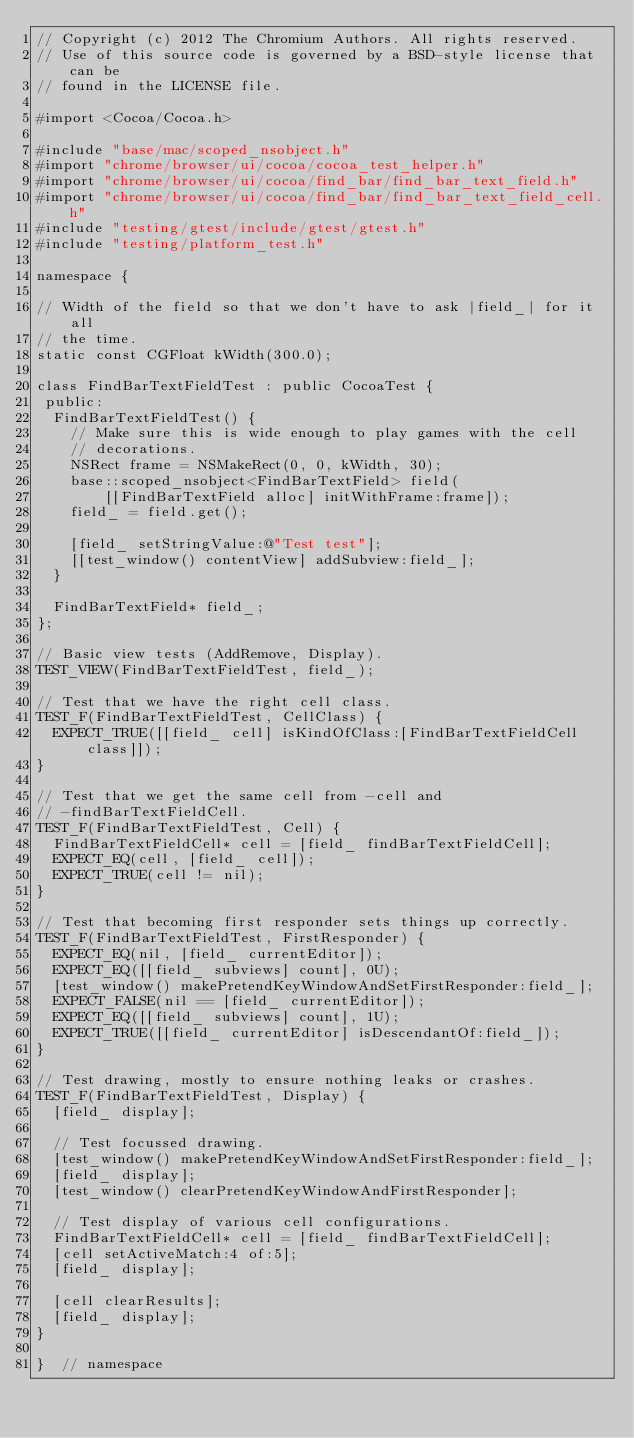<code> <loc_0><loc_0><loc_500><loc_500><_ObjectiveC_>// Copyright (c) 2012 The Chromium Authors. All rights reserved.
// Use of this source code is governed by a BSD-style license that can be
// found in the LICENSE file.

#import <Cocoa/Cocoa.h>

#include "base/mac/scoped_nsobject.h"
#import "chrome/browser/ui/cocoa/cocoa_test_helper.h"
#import "chrome/browser/ui/cocoa/find_bar/find_bar_text_field.h"
#import "chrome/browser/ui/cocoa/find_bar/find_bar_text_field_cell.h"
#include "testing/gtest/include/gtest/gtest.h"
#include "testing/platform_test.h"

namespace {

// Width of the field so that we don't have to ask |field_| for it all
// the time.
static const CGFloat kWidth(300.0);

class FindBarTextFieldTest : public CocoaTest {
 public:
  FindBarTextFieldTest() {
    // Make sure this is wide enough to play games with the cell
    // decorations.
    NSRect frame = NSMakeRect(0, 0, kWidth, 30);
    base::scoped_nsobject<FindBarTextField> field(
        [[FindBarTextField alloc] initWithFrame:frame]);
    field_ = field.get();

    [field_ setStringValue:@"Test test"];
    [[test_window() contentView] addSubview:field_];
  }

  FindBarTextField* field_;
};

// Basic view tests (AddRemove, Display).
TEST_VIEW(FindBarTextFieldTest, field_);

// Test that we have the right cell class.
TEST_F(FindBarTextFieldTest, CellClass) {
  EXPECT_TRUE([[field_ cell] isKindOfClass:[FindBarTextFieldCell class]]);
}

// Test that we get the same cell from -cell and
// -findBarTextFieldCell.
TEST_F(FindBarTextFieldTest, Cell) {
  FindBarTextFieldCell* cell = [field_ findBarTextFieldCell];
  EXPECT_EQ(cell, [field_ cell]);
  EXPECT_TRUE(cell != nil);
}

// Test that becoming first responder sets things up correctly.
TEST_F(FindBarTextFieldTest, FirstResponder) {
  EXPECT_EQ(nil, [field_ currentEditor]);
  EXPECT_EQ([[field_ subviews] count], 0U);
  [test_window() makePretendKeyWindowAndSetFirstResponder:field_];
  EXPECT_FALSE(nil == [field_ currentEditor]);
  EXPECT_EQ([[field_ subviews] count], 1U);
  EXPECT_TRUE([[field_ currentEditor] isDescendantOf:field_]);
}

// Test drawing, mostly to ensure nothing leaks or crashes.
TEST_F(FindBarTextFieldTest, Display) {
  [field_ display];

  // Test focussed drawing.
  [test_window() makePretendKeyWindowAndSetFirstResponder:field_];
  [field_ display];
  [test_window() clearPretendKeyWindowAndFirstResponder];

  // Test display of various cell configurations.
  FindBarTextFieldCell* cell = [field_ findBarTextFieldCell];
  [cell setActiveMatch:4 of:5];
  [field_ display];

  [cell clearResults];
  [field_ display];
}

}  // namespace
</code> 